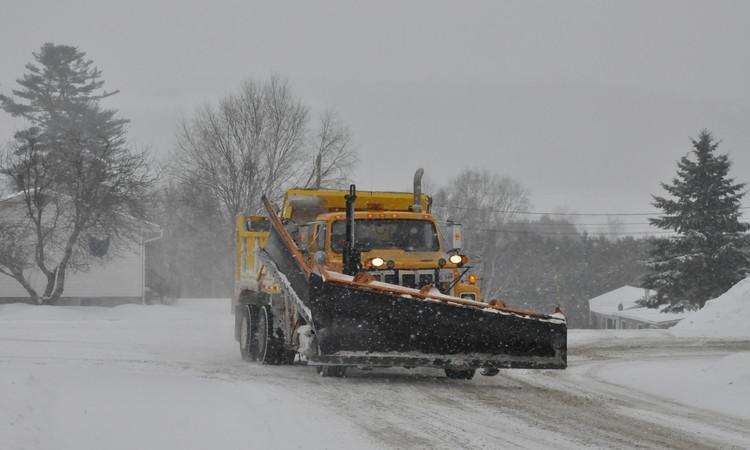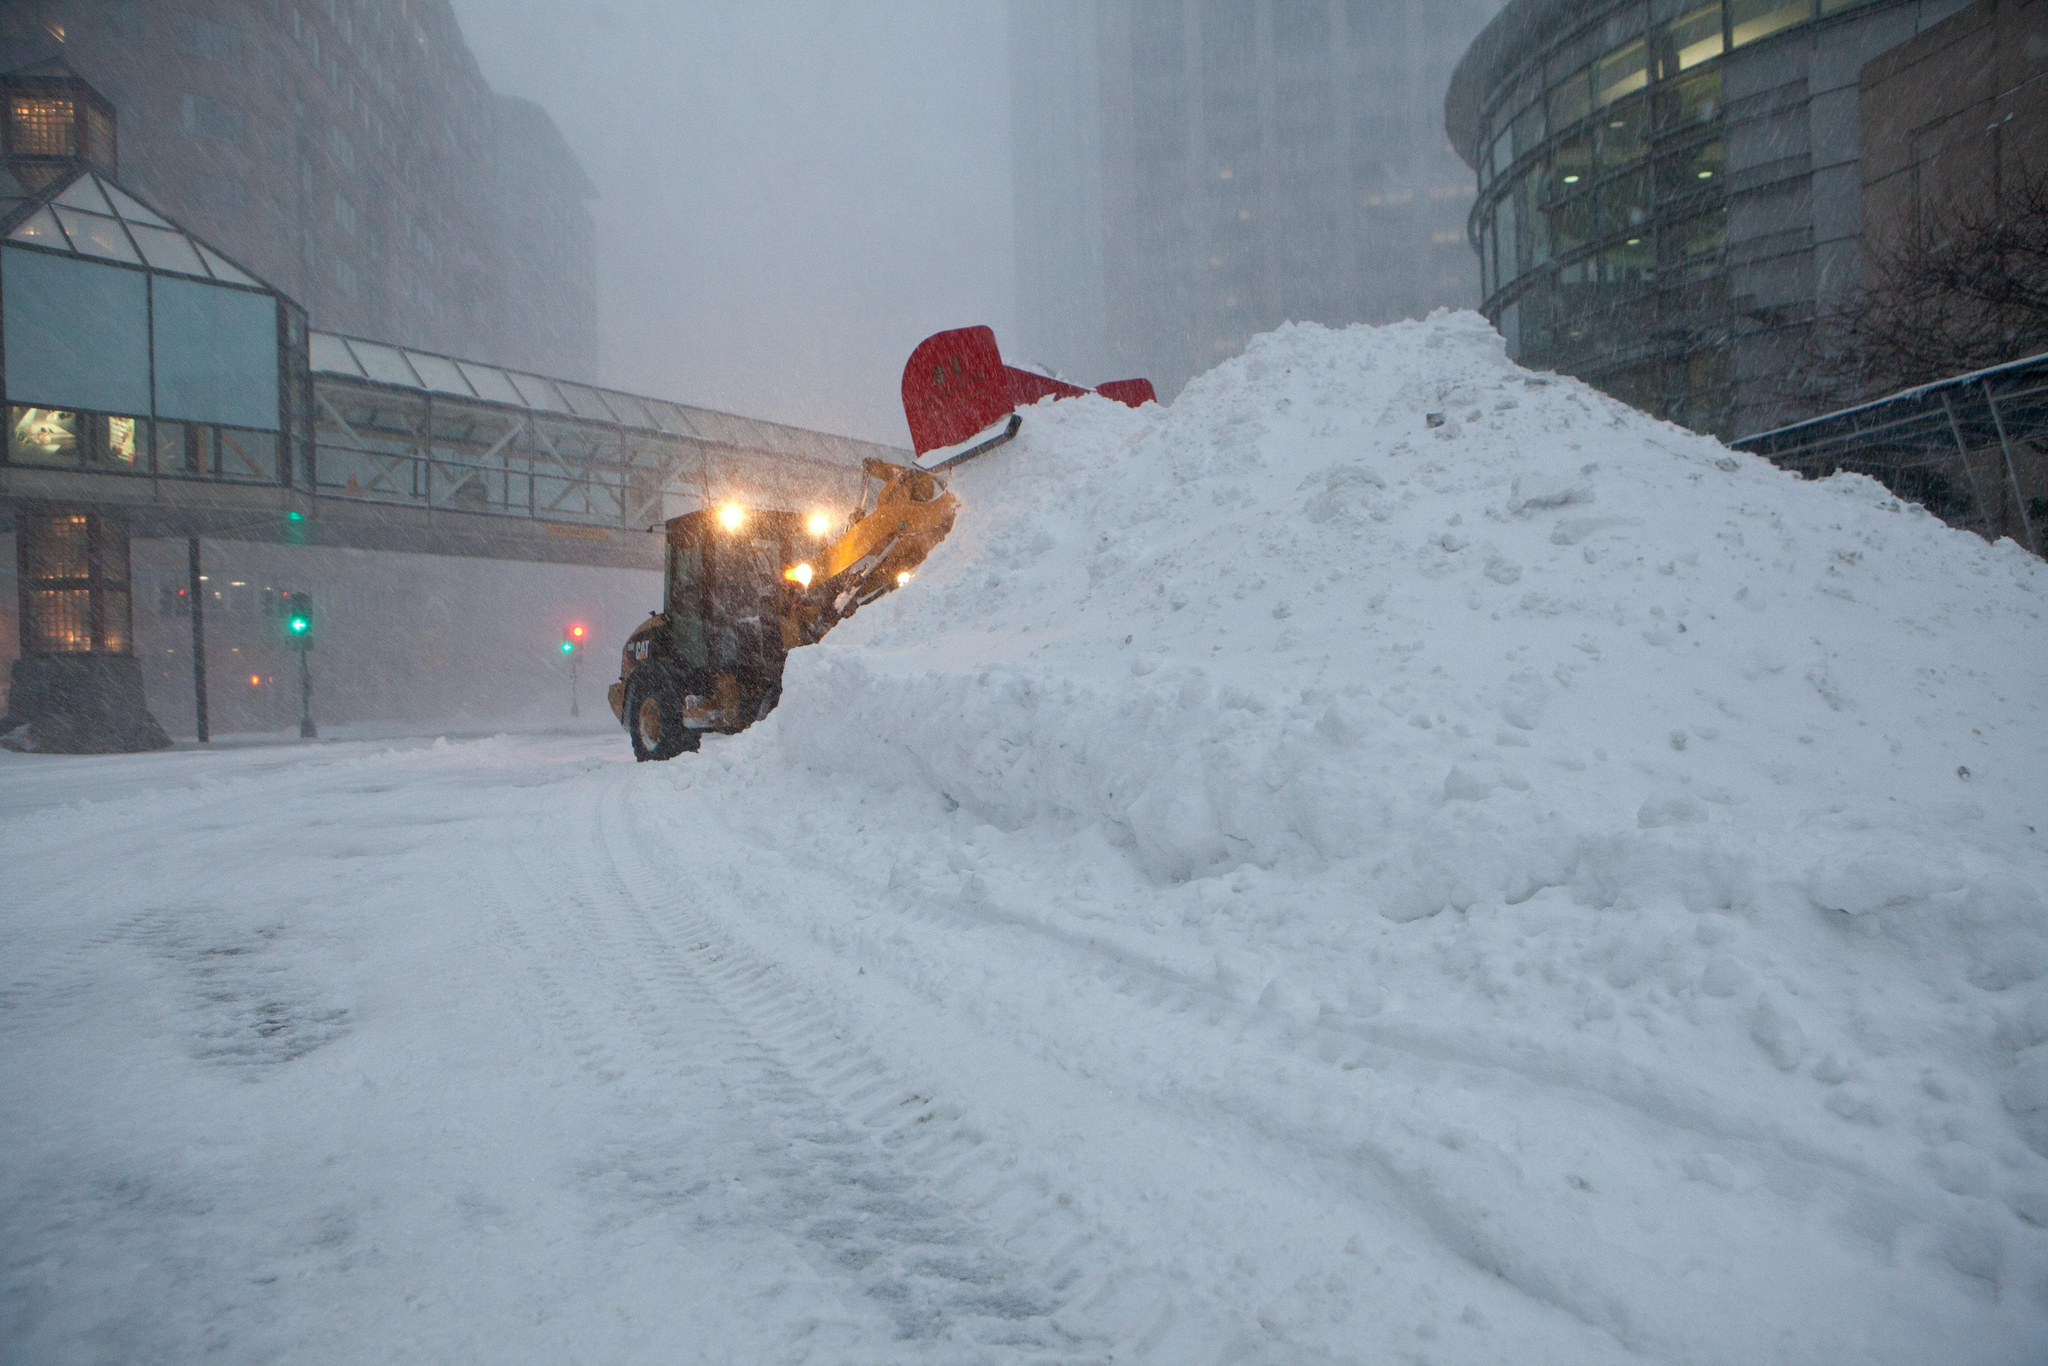The first image is the image on the left, the second image is the image on the right. Examine the images to the left and right. Is the description "there are at least two vehicles in one of the images" accurate? Answer yes or no. No. The first image is the image on the left, the second image is the image on the right. For the images shown, is this caption "More than one snowplow truck is present on a snowy road." true? Answer yes or no. No. 